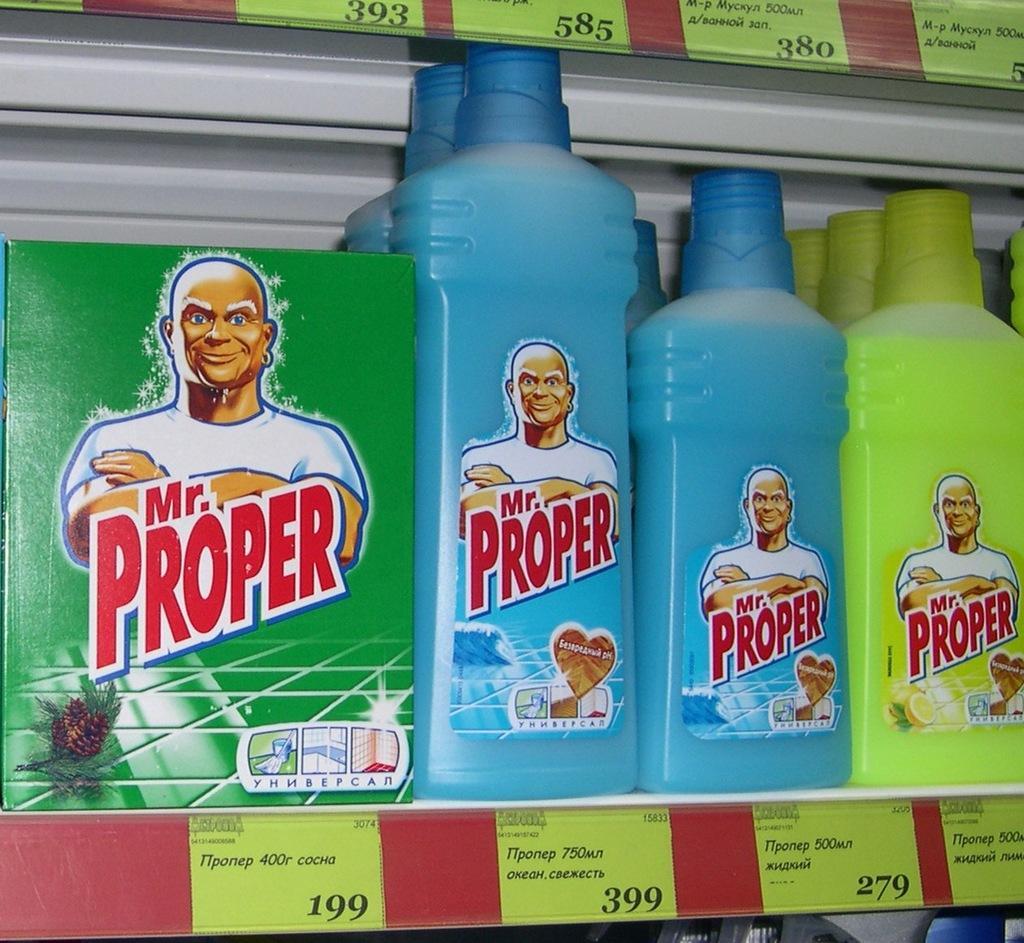Can you describe this image briefly? A picture of a rack. In this race there are bottles and box. This bottles and box name is Mr. Proper. On this rock there are different type of tags. 